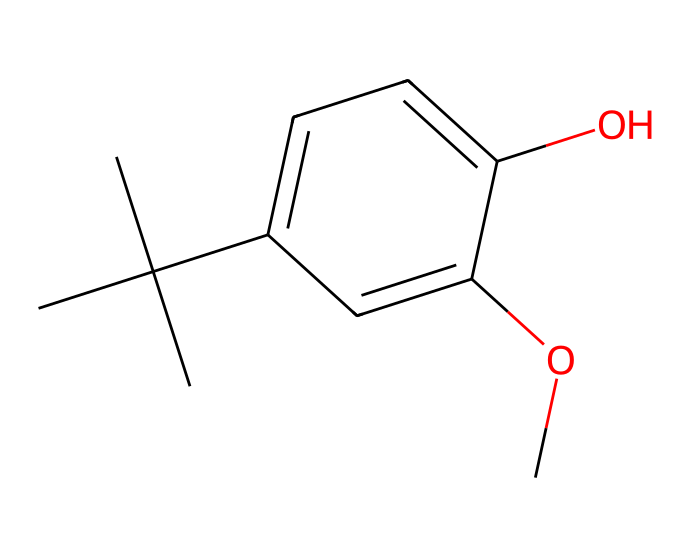What is the common name of this chemical? The SMILES representation indicates the structure corresponds to butylated hydroxyanisole, which is commonly referred to as BHA.
Answer: BHA How many carbon atoms are in the structure? By analyzing the SMILES, the structure reveals a total of 10 carbon atoms, counting those in all branches and rings.
Answer: 10 How many oxygen atoms are present in the molecule? The SMILES indicates two 'O' letters, which represent oxygen atoms in the structure (one in the hydroxyl group and one in the methoxy group).
Answer: 2 What type of additive is BHA classified as? BHA is specifically categorized as a synthetic antioxidant in the food industry, helping to prevent spoilage.
Answer: antioxidant What functional groups are in this molecule? The structure contains a hydroxyl group (-OH) and a methoxy group (-OCH3), which are both significant for its reactivity and functionality.
Answer: hydroxyl and methoxy Is this compound soluble in water? Given the hydrophobic hydrocarbon nature of most of its structure with only small polar functional groups, BHA has low solubility in water.
Answer: low What is the role of BHA in food products? BHA is primarily used to preserve food by preventing oxidation, thus prolonging shelf life and maintaining flavor.
Answer: preserve 